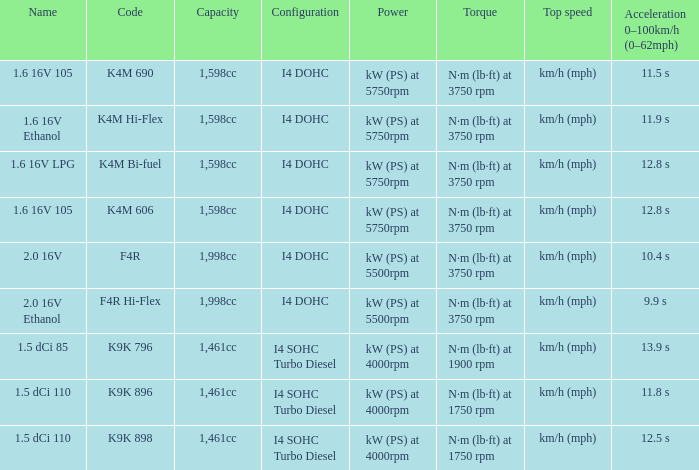5 dci 110, with a size of 1,461cc? K9K 896, K9K 898. 